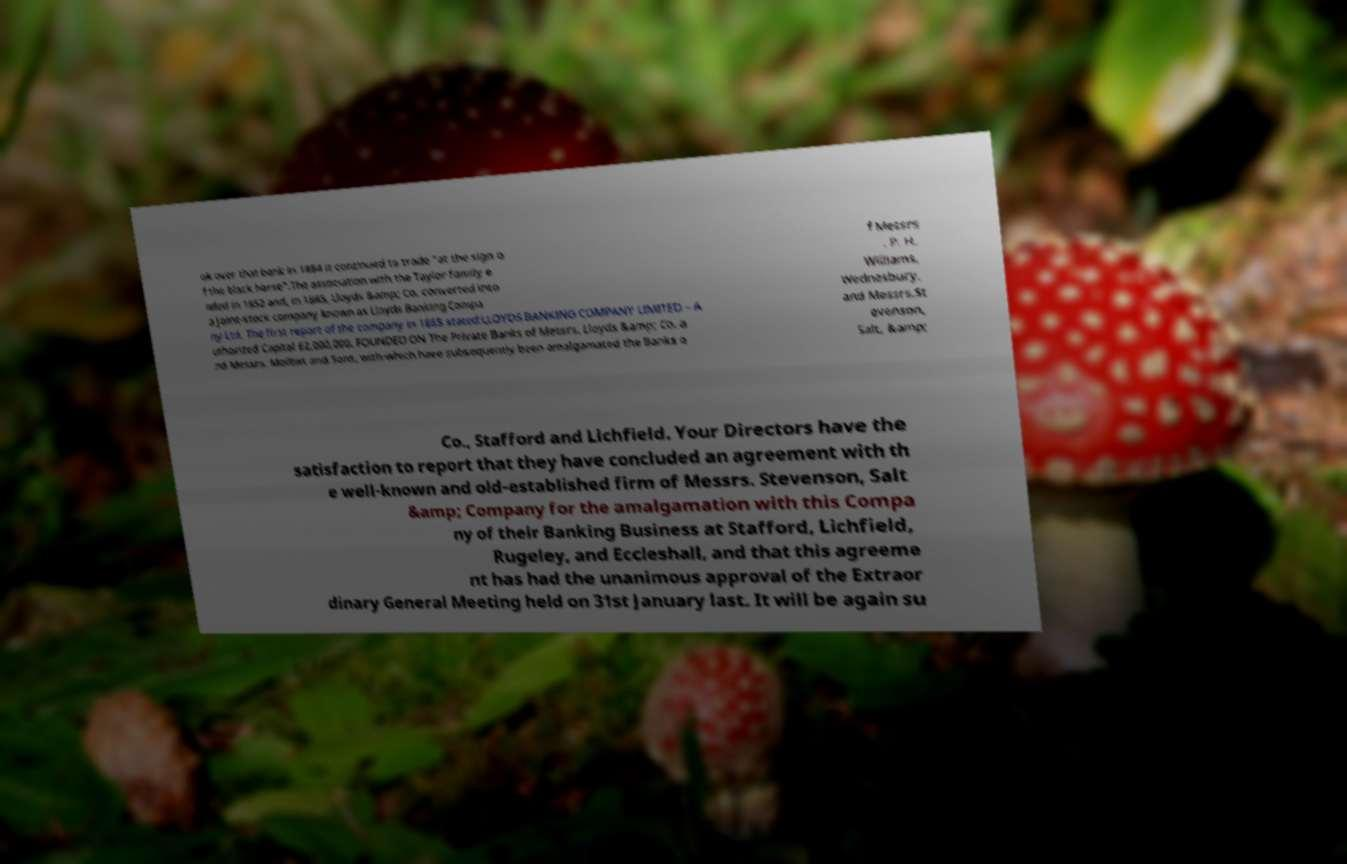What messages or text are displayed in this image? I need them in a readable, typed format. ok over that bank in 1884 it continued to trade "at the sign o f the black horse".The association with the Taylor family e nded in 1852 and, in 1865, Lloyds &amp; Co. converted into a joint-stock company known as Lloyds Banking Compa ny Ltd. The first report of the company in 1865 stated:LLOYDS BANKING COMPANY LIMITED – A uthorized Capital £2,000,000. FOUNDED ON The Private Banks of Messrs. Lloyds &amp; Co. a nd Messrs. Moilliet and Sons, with-which have subsequently been amalgamated the Banks o f Messrs . P. H. Williams, Wednesbury, and Messrs.St evenson, Salt, &amp; Co., Stafford and Lichfield. Your Directors have the satisfaction to report that they have concluded an agreement with th e well-known and old-established firm of Messrs. Stevenson, Salt &amp; Company for the amalgamation with this Compa ny of their Banking Business at Stafford, Lichfield, Rugeley, and Eccleshall, and that this agreeme nt has had the unanimous approval of the Extraor dinary General Meeting held on 31st January last. It will be again su 